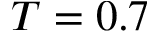Convert formula to latex. <formula><loc_0><loc_0><loc_500><loc_500>T = 0 . 7</formula> 